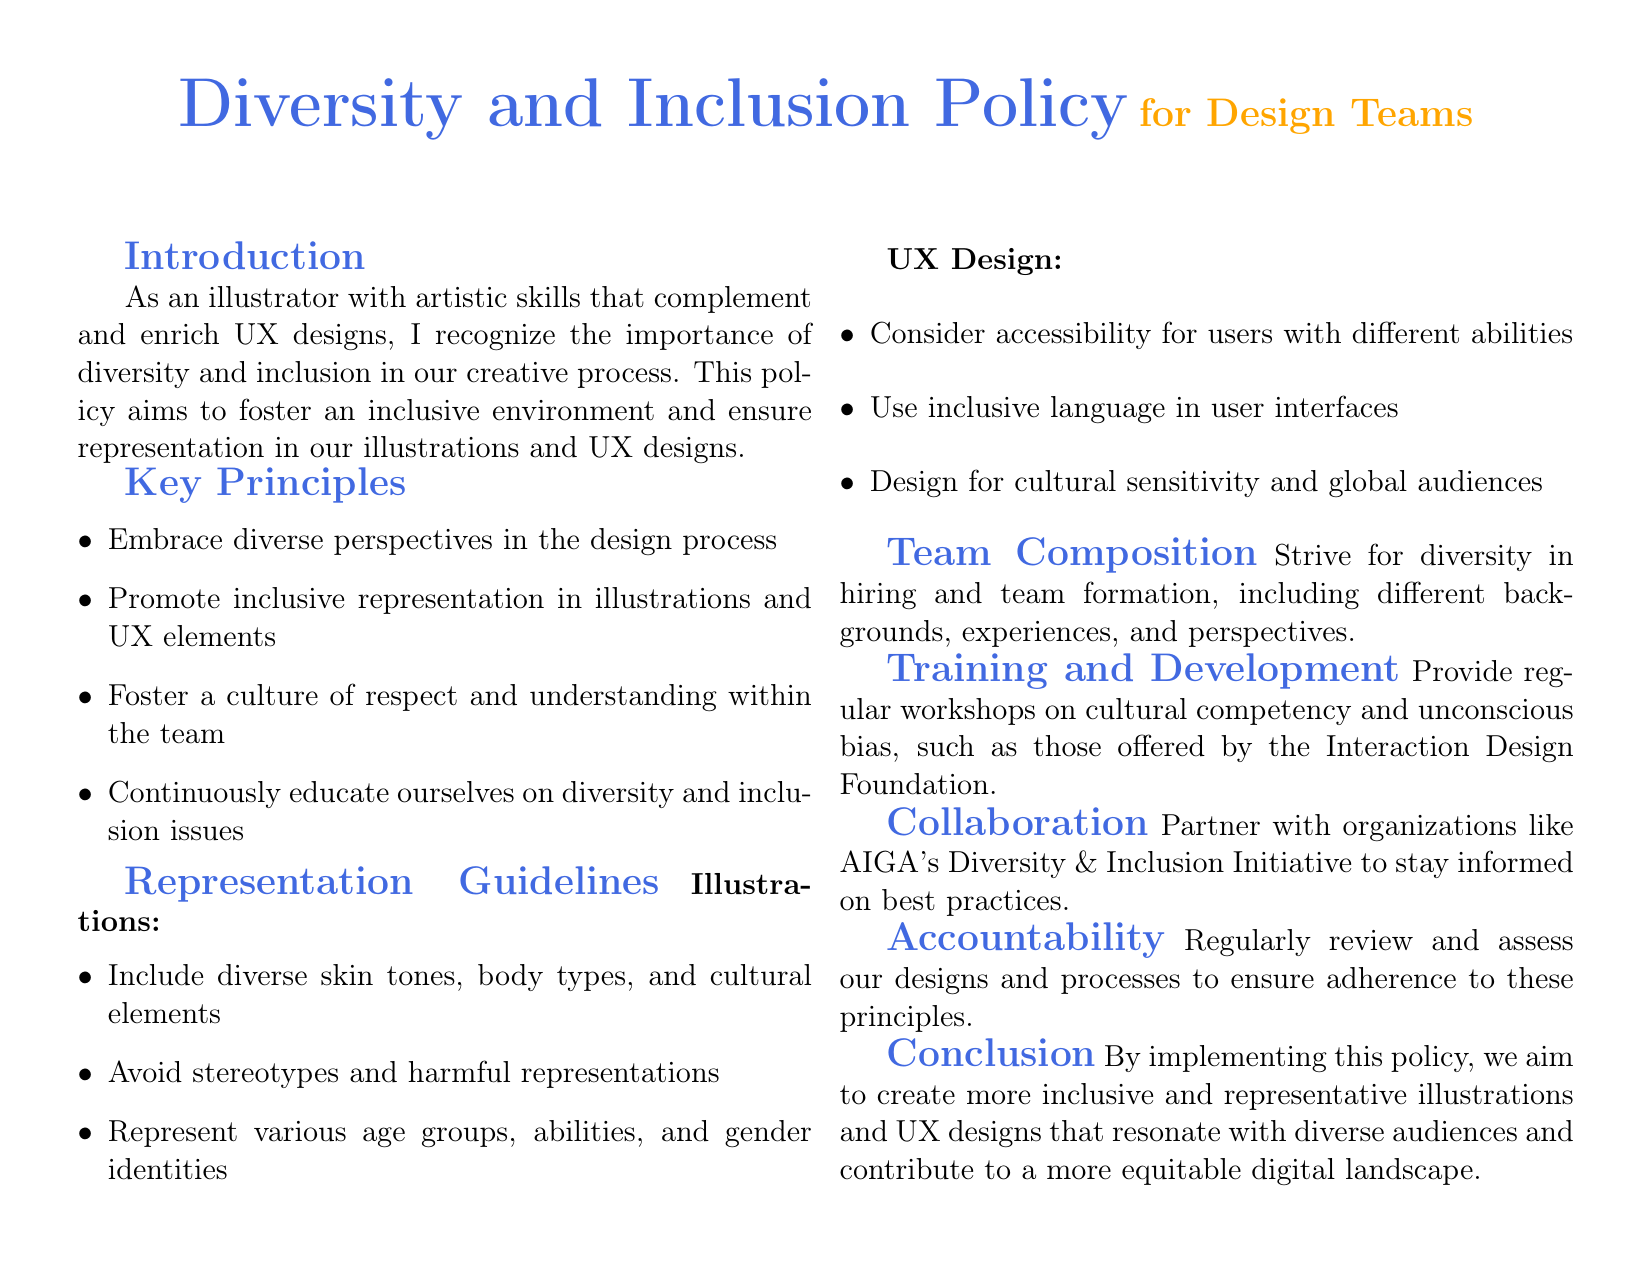What is the main focus of the policy? The policy aims to foster an inclusive environment and ensure representation in our illustrations and UX designs.
Answer: inclusive environment What are the key principles listed in the document? Key principles include embracing diverse perspectives, promoting inclusive representation, fostering a culture of respect, and continuous education.
Answer: diverse perspectives, inclusive representation, respect, education What is one guideline for illustrations mentioned? The guideline emphasizes including diverse skin tones, body types, and cultural elements in illustrations.
Answer: diverse skin tones What does the policy recommend for UX design regarding accessibility? The policy recommends considering accessibility for users with different abilities.
Answer: accessibility for users How should teams be composed according to the policy? Teams should strive for diversity in hiring and team formation, including different backgrounds, experiences, and perspectives.
Answer: diversity in hiring How often should training on cultural competency be provided? The document suggests providing regular workshops on cultural competency and unconscious bias.
Answer: regular workshops What organization is mentioned for collaboration on diversity practices? The policy mentions partnering with AIGA's Diversity & Inclusion Initiative.
Answer: AIGA What should be regularly reviewed to ensure adherence to the policy? The document states that designs and processes should be regularly reviewed and assessed.
Answer: designs and processes What is the ultimate goal of implementing this policy? The ultimate goal is to create more inclusive and representative illustrations and UX designs.
Answer: inclusive and representative designs 